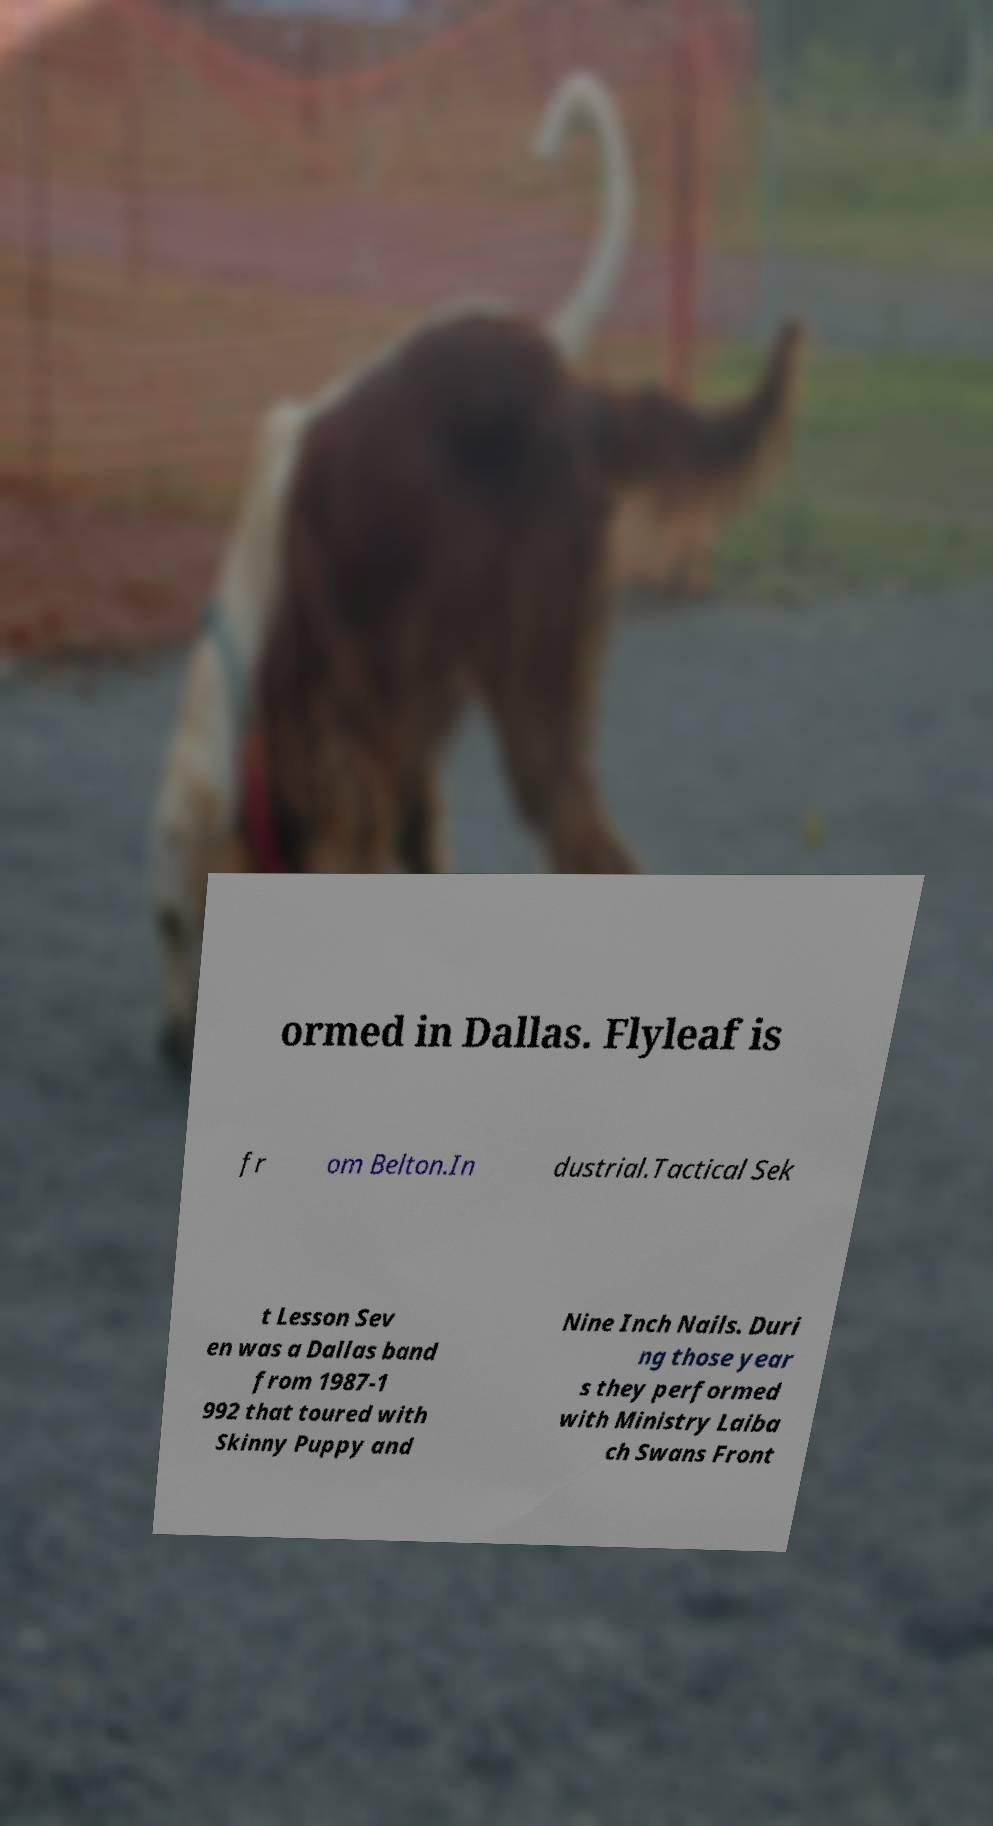Please identify and transcribe the text found in this image. ormed in Dallas. Flyleaf is fr om Belton.In dustrial.Tactical Sek t Lesson Sev en was a Dallas band from 1987-1 992 that toured with Skinny Puppy and Nine Inch Nails. Duri ng those year s they performed with Ministry Laiba ch Swans Front 